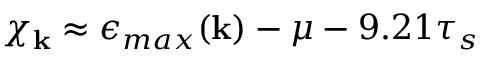Convert formula to latex. <formula><loc_0><loc_0><loc_500><loc_500>\chi _ { k } \approx \epsilon _ { \max } ( { k } ) - \mu - 9 . 2 1 \tau _ { s }</formula> 